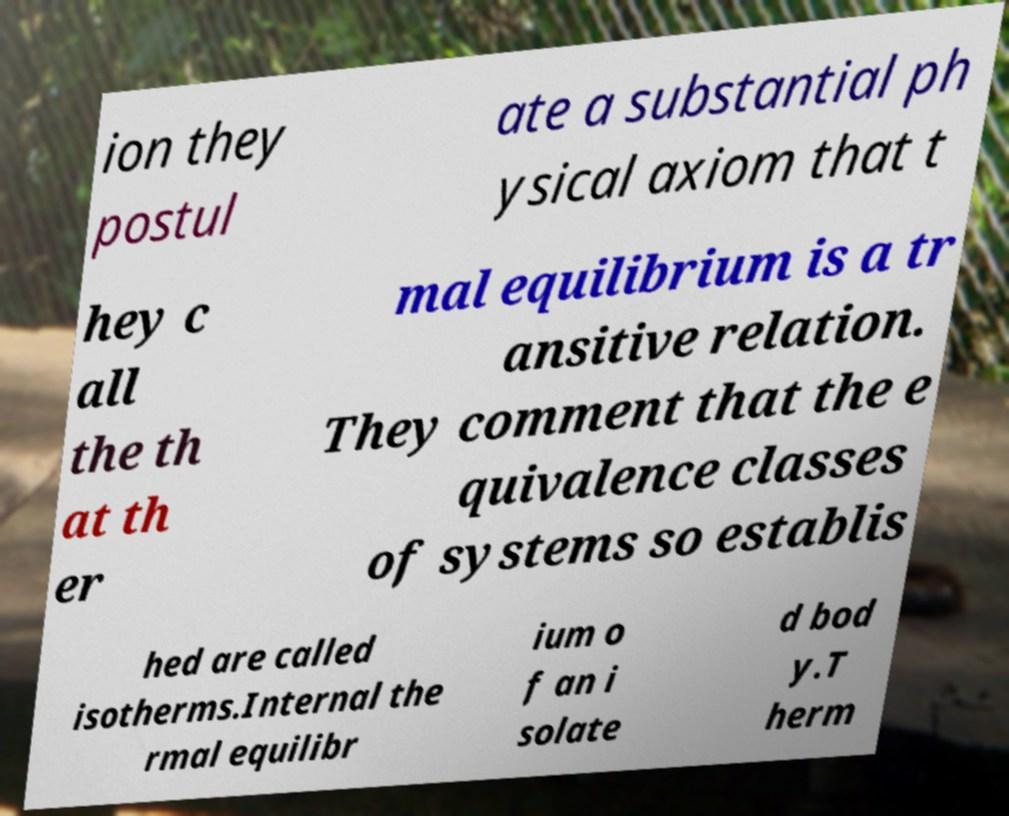Can you accurately transcribe the text from the provided image for me? ion they postul ate a substantial ph ysical axiom that t hey c all the th at th er mal equilibrium is a tr ansitive relation. They comment that the e quivalence classes of systems so establis hed are called isotherms.Internal the rmal equilibr ium o f an i solate d bod y.T herm 